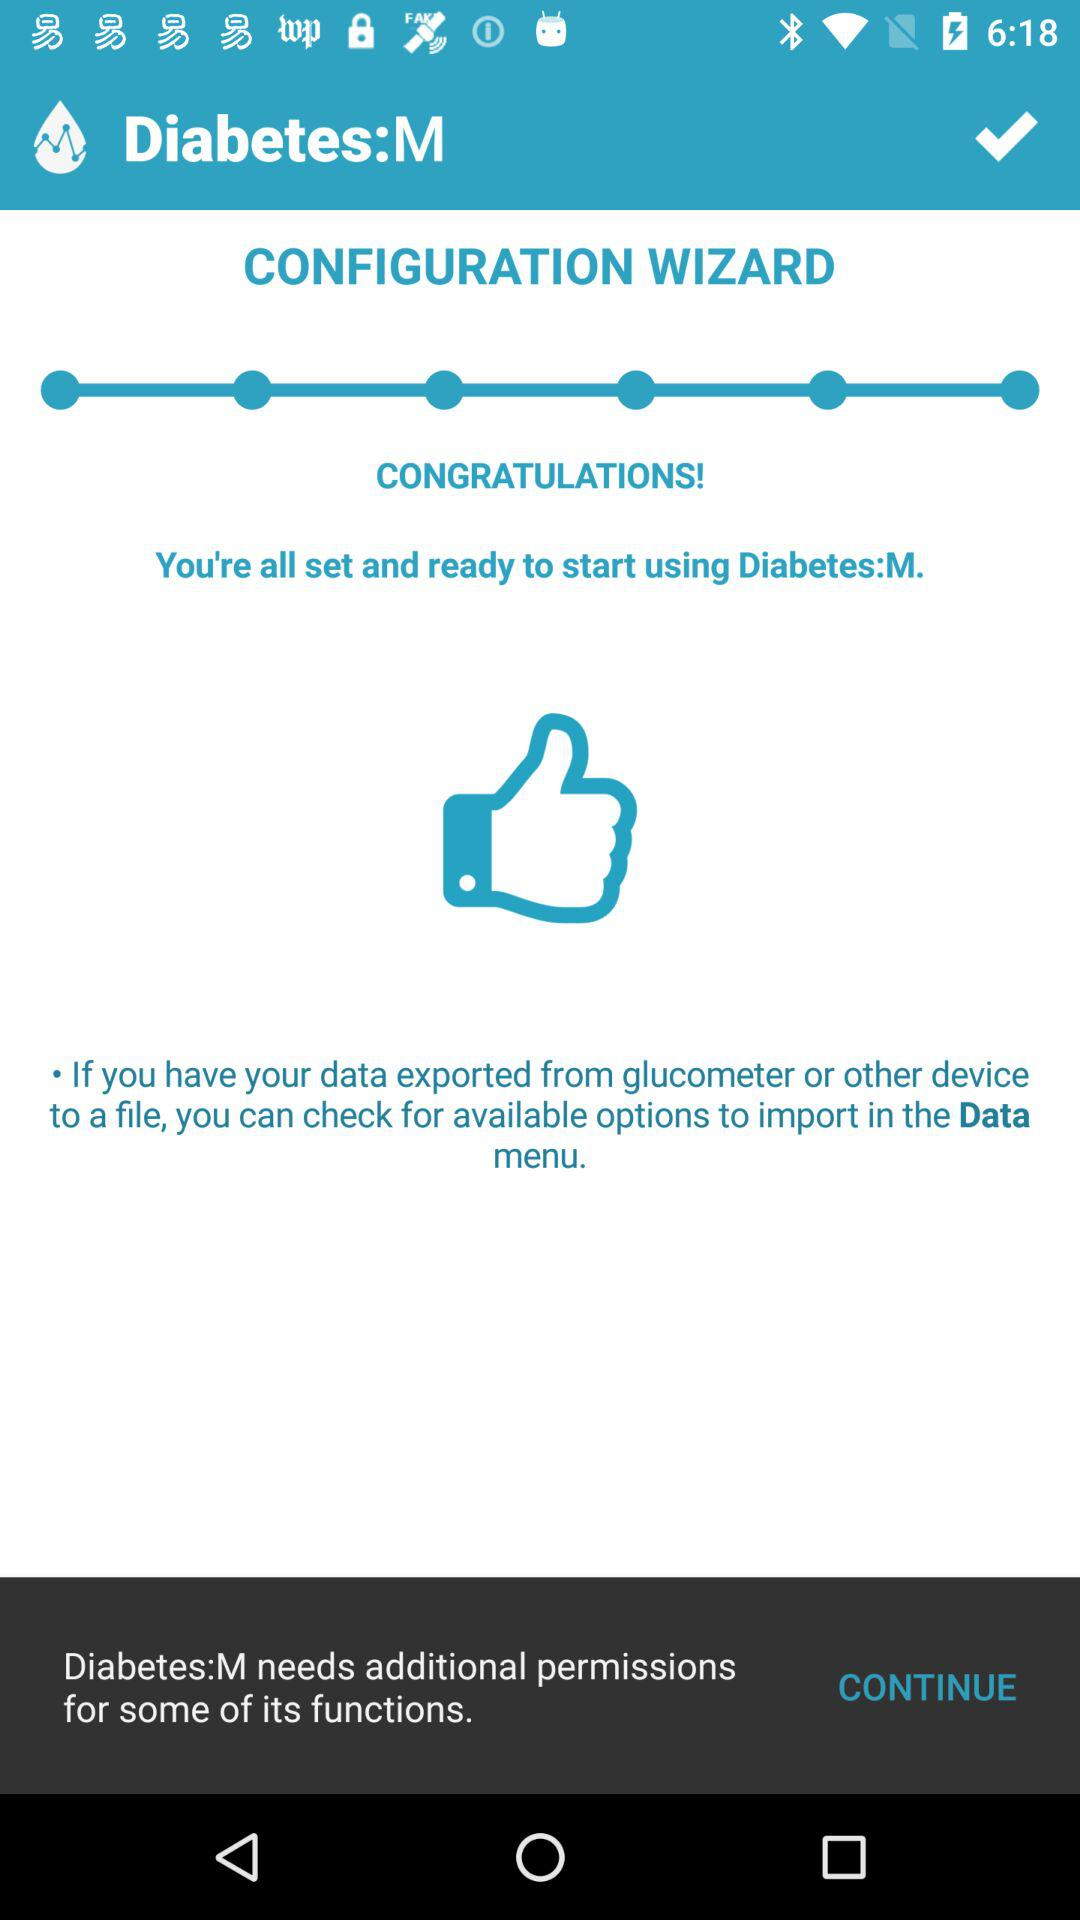What is the application name? The application name is "Diabetes:M". 